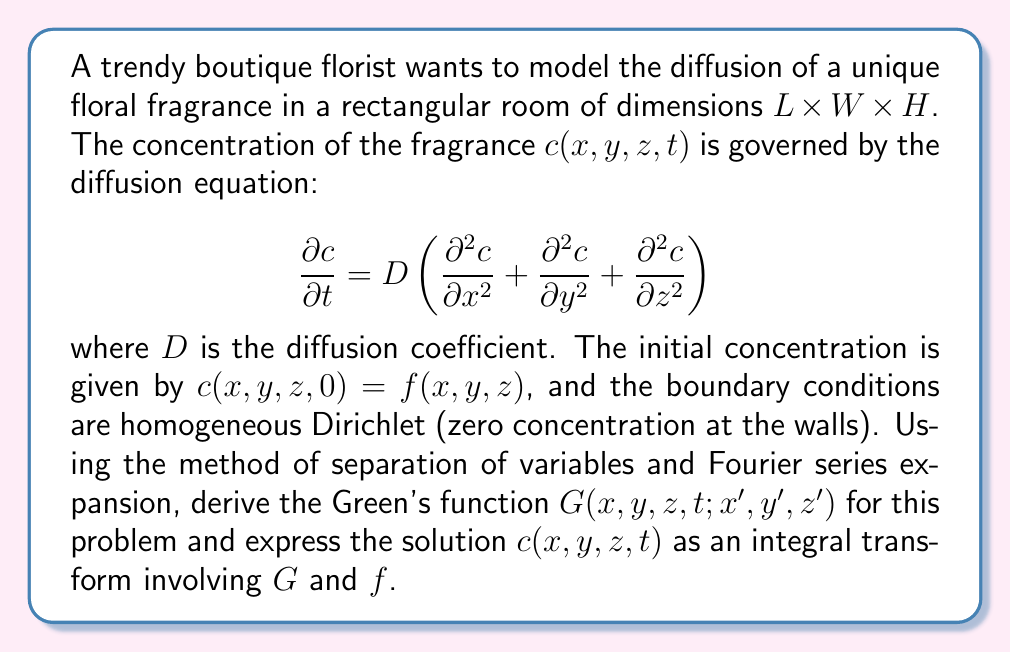What is the answer to this math problem? 1) First, we separate variables: $c(x,y,z,t) = X(x)Y(y)Z(z)T(t)$

2) Substituting into the diffusion equation and dividing by $c$:

   $$\frac{1}{D}\frac{1}{T}\frac{dT}{dt} = \frac{1}{X}\frac{d^2X}{dx^2} + \frac{1}{Y}\frac{d^2Y}{dy^2} + \frac{1}{Z}\frac{d^2Z}{dz^2} = -\lambda^2$$

3) This leads to four ODEs:
   
   $$\frac{dT}{dt} + D\lambda^2T = 0$$
   $$\frac{d^2X}{dx^2} + \lambda_x^2X = 0$$
   $$\frac{d^2Y}{dy^2} + \lambda_y^2Y = 0$$
   $$\frac{d^2Z}{dz^2} + \lambda_z^2Z = 0$$

   where $\lambda^2 = \lambda_x^2 + \lambda_y^2 + \lambda_z^2$

4) Solving these with the boundary conditions:

   $$X_n(x) = \sin(\frac{n\pi x}{L}), \quad Y_m(y) = \sin(\frac{m\pi y}{W}), \quad Z_k(z) = \sin(\frac{k\pi z}{H})$$
   $$T_{nmk}(t) = e^{-D(\frac{n^2\pi^2}{L^2} + \frac{m^2\pi^2}{W^2} + \frac{k^2\pi^2}{H^2})t}$$

5) The Green's function is the product of these solutions:

   $$G(x,y,z,t;x',y',z') = \sum_{n=1}^{\infty}\sum_{m=1}^{\infty}\sum_{k=1}^{\infty} \frac{8}{LWH} \sin(\frac{n\pi x}{L})\sin(\frac{m\pi y}{W})\sin(\frac{k\pi z}{H})$$
   $$\times \sin(\frac{n\pi x'}{L})\sin(\frac{m\pi y'}{W})\sin(\frac{k\pi z'}{H}) e^{-D(\frac{n^2\pi^2}{L^2} + \frac{m^2\pi^2}{W^2} + \frac{k^2\pi^2}{H^2})t}$$

6) The solution $c(x,y,z,t)$ is given by the integral transform:

   $$c(x,y,z,t) = \int_0^L\int_0^W\int_0^H G(x,y,z,t;x',y',z')f(x',y',z') dx'dy'dz'$$
Answer: $c(x,y,z,t) = \int_0^L\int_0^W\int_0^H G(x,y,z,t;x',y',z')f(x',y',z') dx'dy'dz'$ 